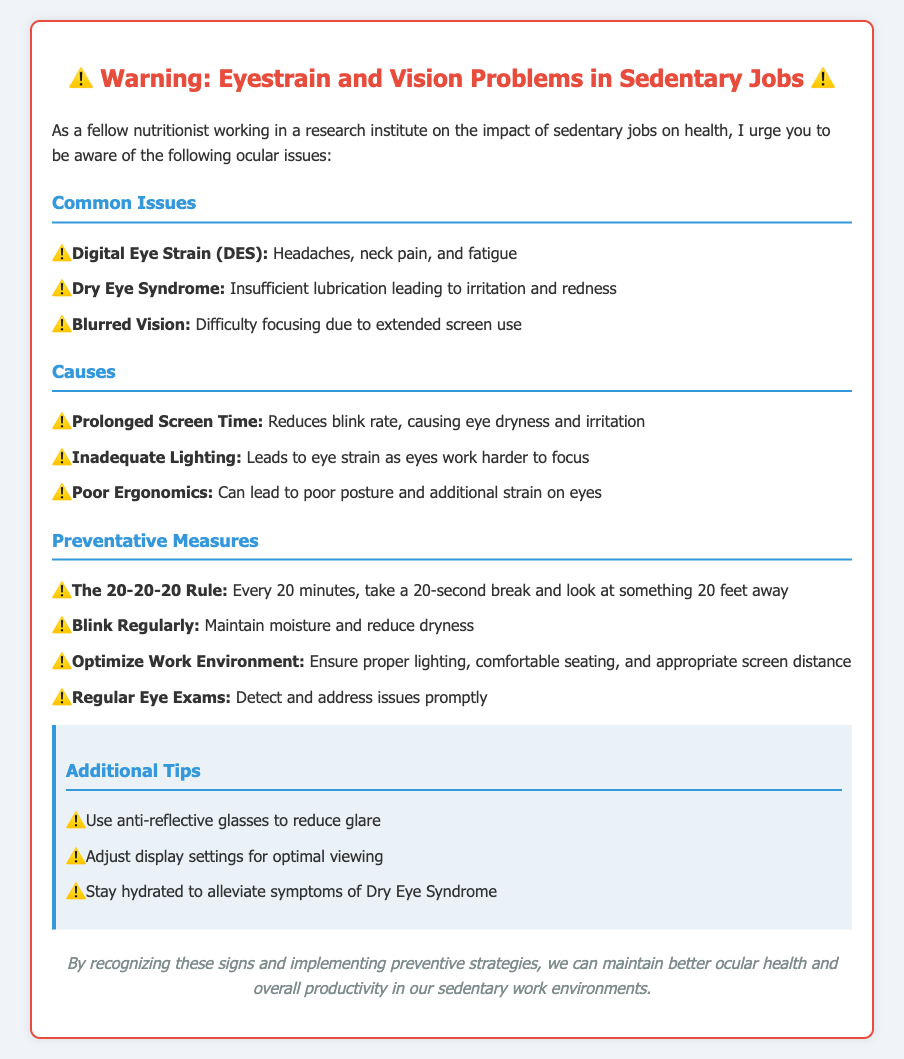What is the title of the warning label? The title is indicated at the top of the document and describes the content's focus on ocular issues in sedentary jobs.
Answer: ⚠️ Warning: Eyestrain and Vision Problems in Sedentary Jobs ⚠️ What is Digital Eye Strain characterized by? The document lists symptoms associated with Digital Eye Strain under Common Issues, which include headaches, neck pain, and fatigue.
Answer: Headaches, neck pain, and fatigue What is one cause of eye strain mentioned? The causes section details factors contributing to eye strain, one of which is prolonged screen time.
Answer: Prolonged Screen Time What is the 20-20-20 Rule? This preventative measure is described in the context of alleviating eye strain by taking breaks; specifically, it involves looking at something 20 feet away for 20 seconds every 20 minutes.
Answer: Every 20 minutes, take a 20-second break and look at something 20 feet away What are anti-reflective glasses used for? The additional tips section includes a recommendation related to reducing glare, which is the intended purpose of anti-reflective glasses.
Answer: To reduce glare How should one maintain moisture for their eyes? The document suggests blinking regularly as a method to ensure eyes remain moist.
Answer: Blink Regularly 